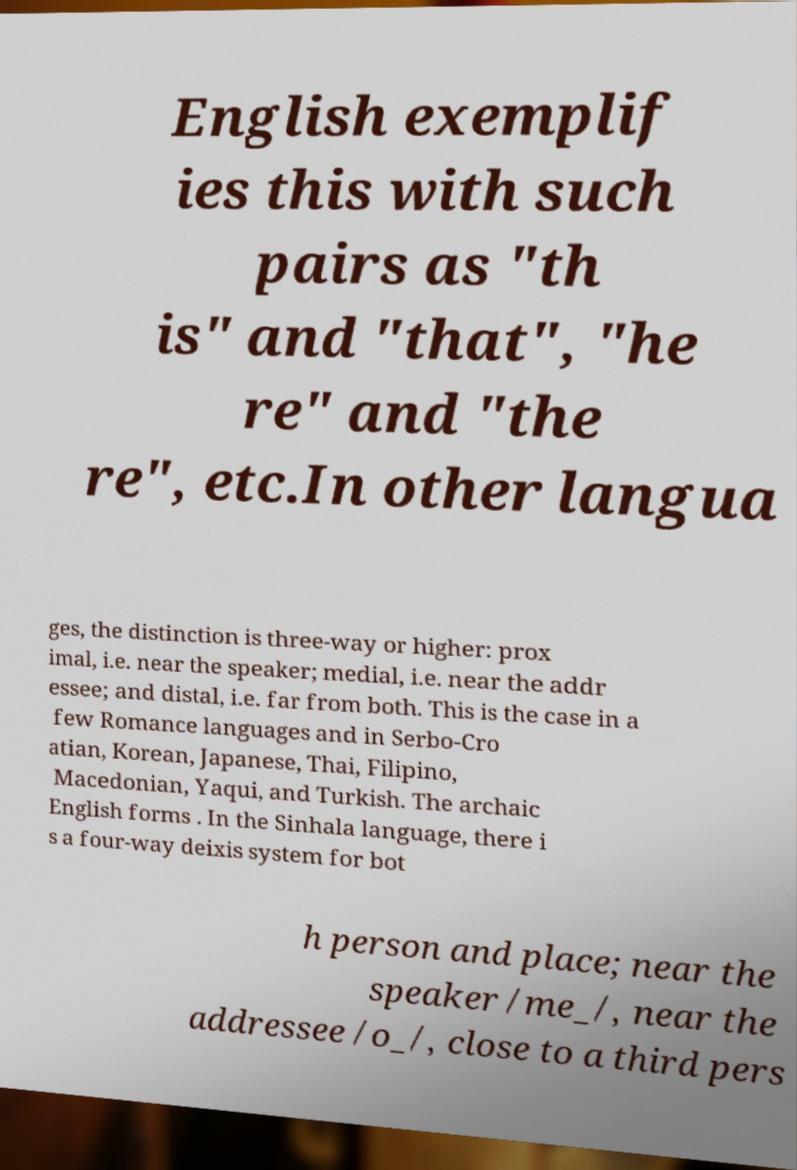What messages or text are displayed in this image? I need them in a readable, typed format. English exemplif ies this with such pairs as "th is" and "that", "he re" and "the re", etc.In other langua ges, the distinction is three-way or higher: prox imal, i.e. near the speaker; medial, i.e. near the addr essee; and distal, i.e. far from both. This is the case in a few Romance languages and in Serbo-Cro atian, Korean, Japanese, Thai, Filipino, Macedonian, Yaqui, and Turkish. The archaic English forms . In the Sinhala language, there i s a four-way deixis system for bot h person and place; near the speaker /me_/, near the addressee /o_/, close to a third pers 